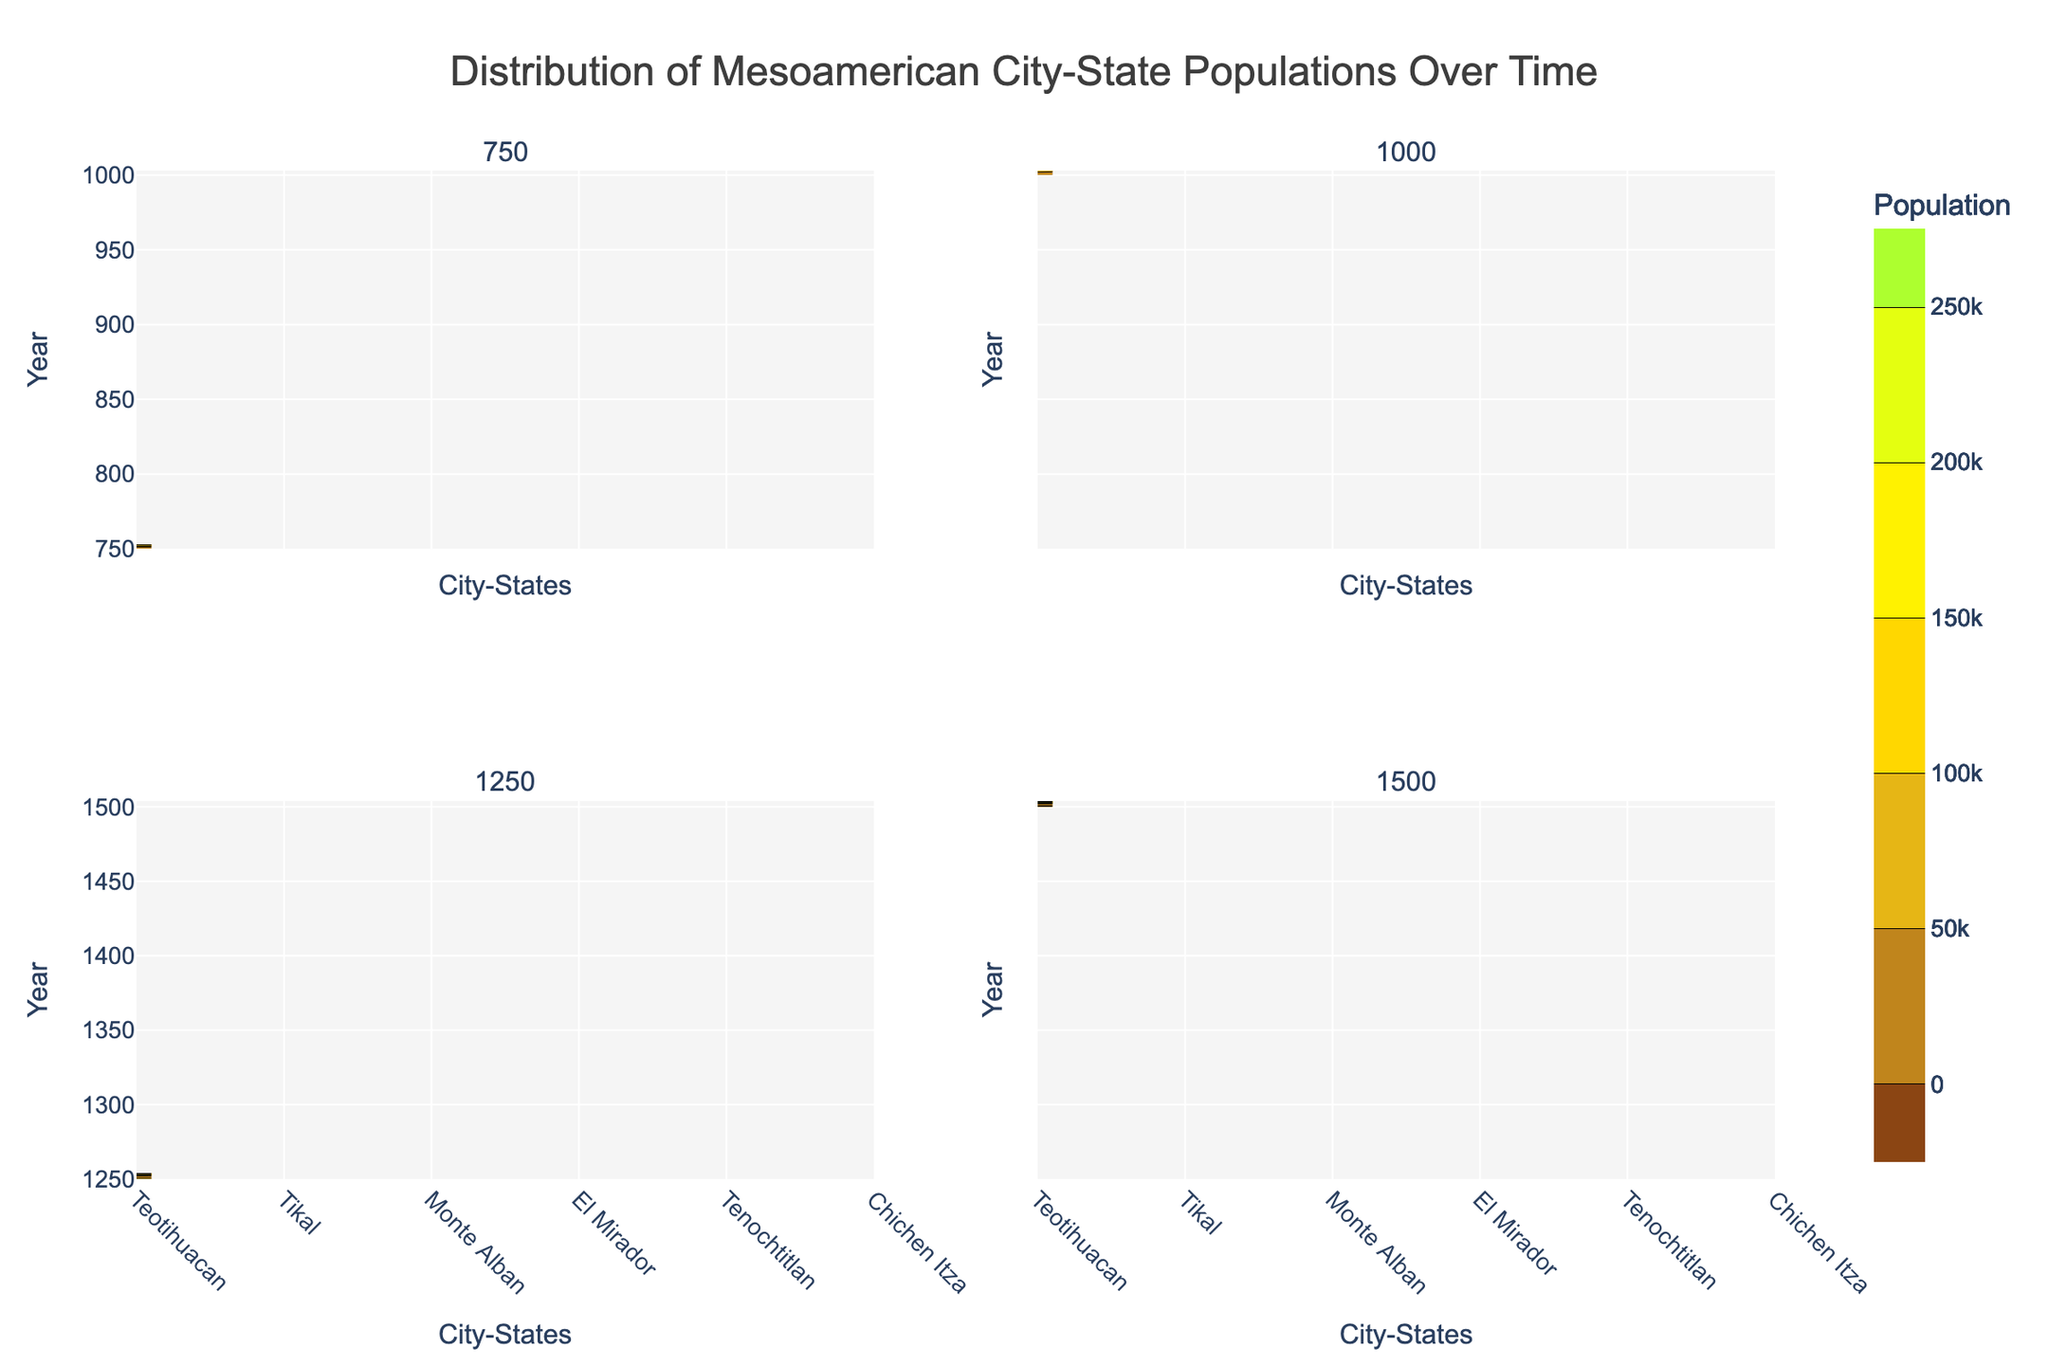What's the highest population recorded in the figure? The highest population recorded can be determined by looking at the contour levels and the color intensity in the plot. The figure shows the highest population recorded is 250,000 for Tenochtitlan in the year 1500.
Answer: 250,000 Which city-state had a declining population over time? To find which city-state had a declining population, we need to look at the contours for each city-state over the years. Teotihuacan's population decreased from 150,000 in 750 to 50,000 in 1000.
Answer: Teotihuacan What was the population of Tikal in the year 1000? Refer to the subplot for the year 1000, locate Tikal, and find the corresponding population value, which is 55,000.
Answer: 55,000 Compare the population of Tenochtitlan between 1250 and 1500. Did it increase or decrease? To compare, look at the contours for Tenochtitlan in the subplots for the years 1250 and 1500. The population increased from 200,000 in 1250 to 250,000 in 1500.
Answer: Increased Which year has the highest variation in city-state populations? The year with the highest variation can be identified by looking at the range of population values (contours) for that year. In 1500, populations range from 20,000 to 250,000, showing the highest variation.
Answer: 1500 How did the population of El Mirador change from 750 to 1500? To identify the change, compare the population values of El Mirador in the subplots for 750 and 1500. It increased from 5,000 in 750 to 20,000 in 1500.
Answer: Increased In which year did Monte Alban have its highest recorded population? Check each subplot's contour levels for Monte Alban and its corresponding population values. The highest recorded population for Monte Alban is 35,000 in 1500.
Answer: 1500 What is the population difference of Chichen Itza between 1250 and 1500? To find the difference, subtract the population of Chichen Itza in 1250 (100,000) from its population in 1500 (120,000). The difference is 20,000.
Answer: 20,000 Identify the city-state with the smallest population in 1250. Refer to the subplot for the year 1250 and find the city-state with the least contour level, which is El Mirador with 15,000.
Answer: El Mirador Did the population of Monte Alban increase or decrease between 1000 and 1250? Comparing the population values for Monte Alban in the subplots for 1000 and 1250, the population increased from 25,000 in 1000 to 30,000 in 1250.
Answer: Increased 